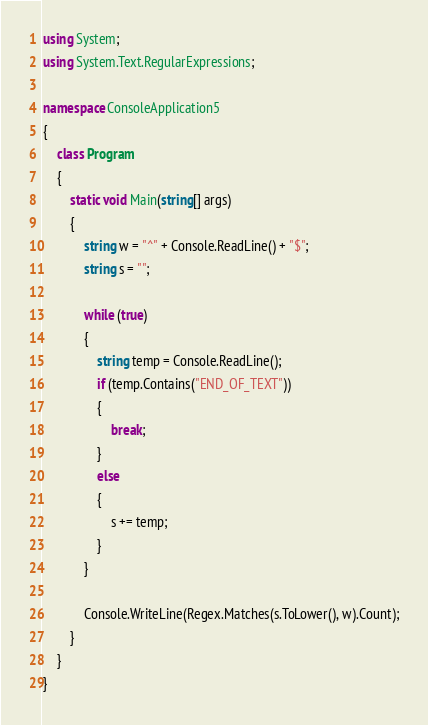Convert code to text. <code><loc_0><loc_0><loc_500><loc_500><_C#_>using System;
using System.Text.RegularExpressions;

namespace ConsoleApplication5
{
    class Program
    {
        static void Main(string[] args)
        {
            string w = "^" + Console.ReadLine() + "$";
            string s = "";

            while (true)
            {
                string temp = Console.ReadLine();
                if (temp.Contains("END_OF_TEXT"))
                {
                    break;
                }
                else
                {
                    s += temp;
                }
            }

            Console.WriteLine(Regex.Matches(s.ToLower(), w).Count);
        }
    }
}</code> 